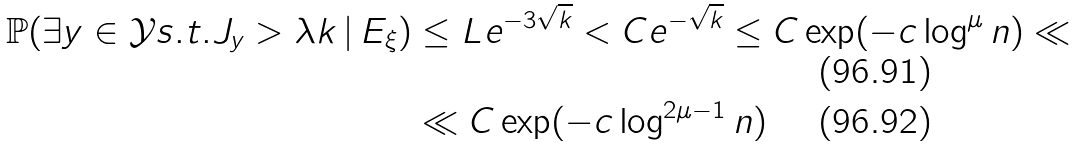<formula> <loc_0><loc_0><loc_500><loc_500>\mathbb { P } ( \exists y \in \mathcal { Y } s . t . J _ { y } > \lambda k \, | \, E _ { \xi } ) & \leq L e ^ { - 3 \sqrt { k } } < C e ^ { - \sqrt { k } } \leq C \exp ( - c \log ^ { \mu } n ) \ll \\ & \ll C \exp ( - c \log ^ { 2 \mu - 1 } n )</formula> 